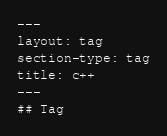<code> <loc_0><loc_0><loc_500><loc_500><_HTML_>---
layout: tag
section-type: tag
title: c++
---
## Tag</code> 